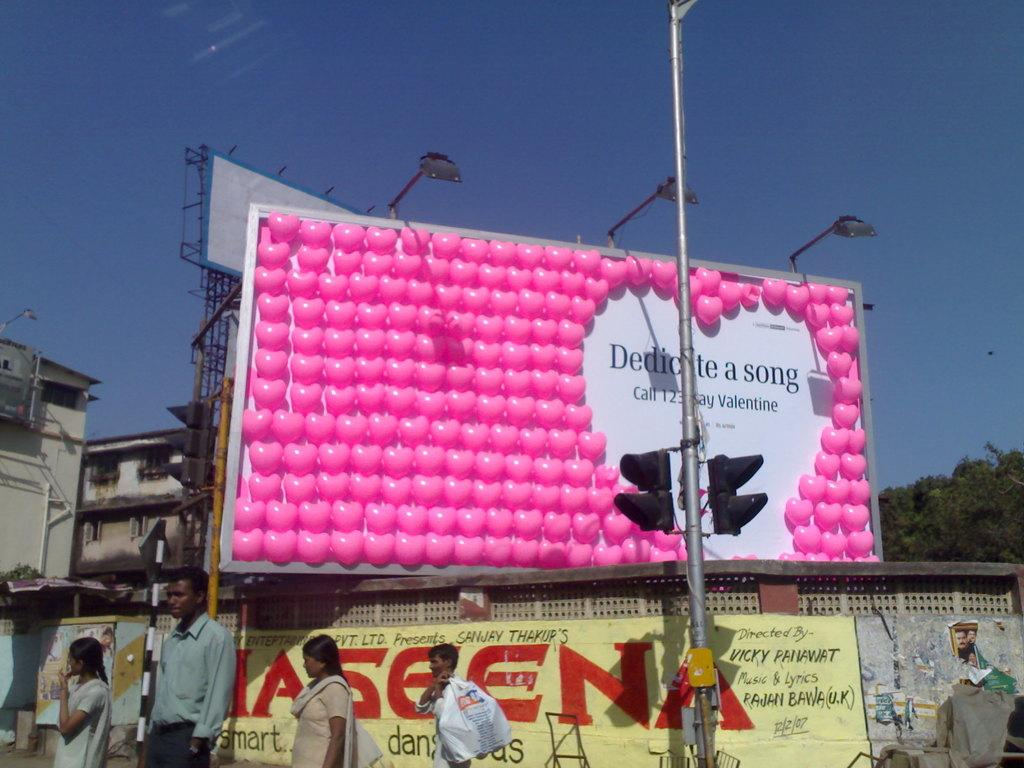<image>
Create a compact narrative representing the image presented. A billboard with pink hearts has the word song on it. 